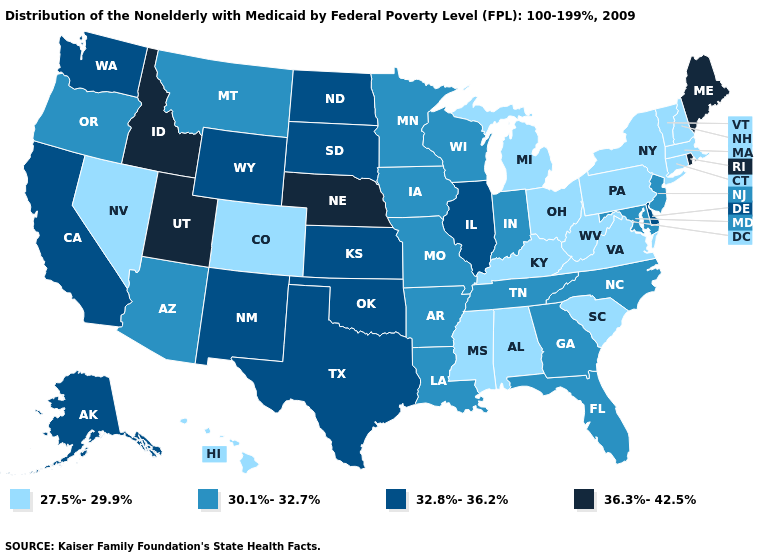What is the value of Hawaii?
Answer briefly. 27.5%-29.9%. Is the legend a continuous bar?
Keep it brief. No. Is the legend a continuous bar?
Be succinct. No. What is the value of Indiana?
Answer briefly. 30.1%-32.7%. What is the value of Iowa?
Write a very short answer. 30.1%-32.7%. Which states hav the highest value in the Northeast?
Keep it brief. Maine, Rhode Island. Name the states that have a value in the range 30.1%-32.7%?
Write a very short answer. Arizona, Arkansas, Florida, Georgia, Indiana, Iowa, Louisiana, Maryland, Minnesota, Missouri, Montana, New Jersey, North Carolina, Oregon, Tennessee, Wisconsin. Does New Jersey have the same value as Illinois?
Answer briefly. No. Does Maine have the highest value in the USA?
Be succinct. Yes. Among the states that border Connecticut , does Massachusetts have the highest value?
Quick response, please. No. Does the first symbol in the legend represent the smallest category?
Write a very short answer. Yes. Name the states that have a value in the range 27.5%-29.9%?
Give a very brief answer. Alabama, Colorado, Connecticut, Hawaii, Kentucky, Massachusetts, Michigan, Mississippi, Nevada, New Hampshire, New York, Ohio, Pennsylvania, South Carolina, Vermont, Virginia, West Virginia. Name the states that have a value in the range 30.1%-32.7%?
Short answer required. Arizona, Arkansas, Florida, Georgia, Indiana, Iowa, Louisiana, Maryland, Minnesota, Missouri, Montana, New Jersey, North Carolina, Oregon, Tennessee, Wisconsin. What is the value of North Dakota?
Short answer required. 32.8%-36.2%. Does the map have missing data?
Short answer required. No. 